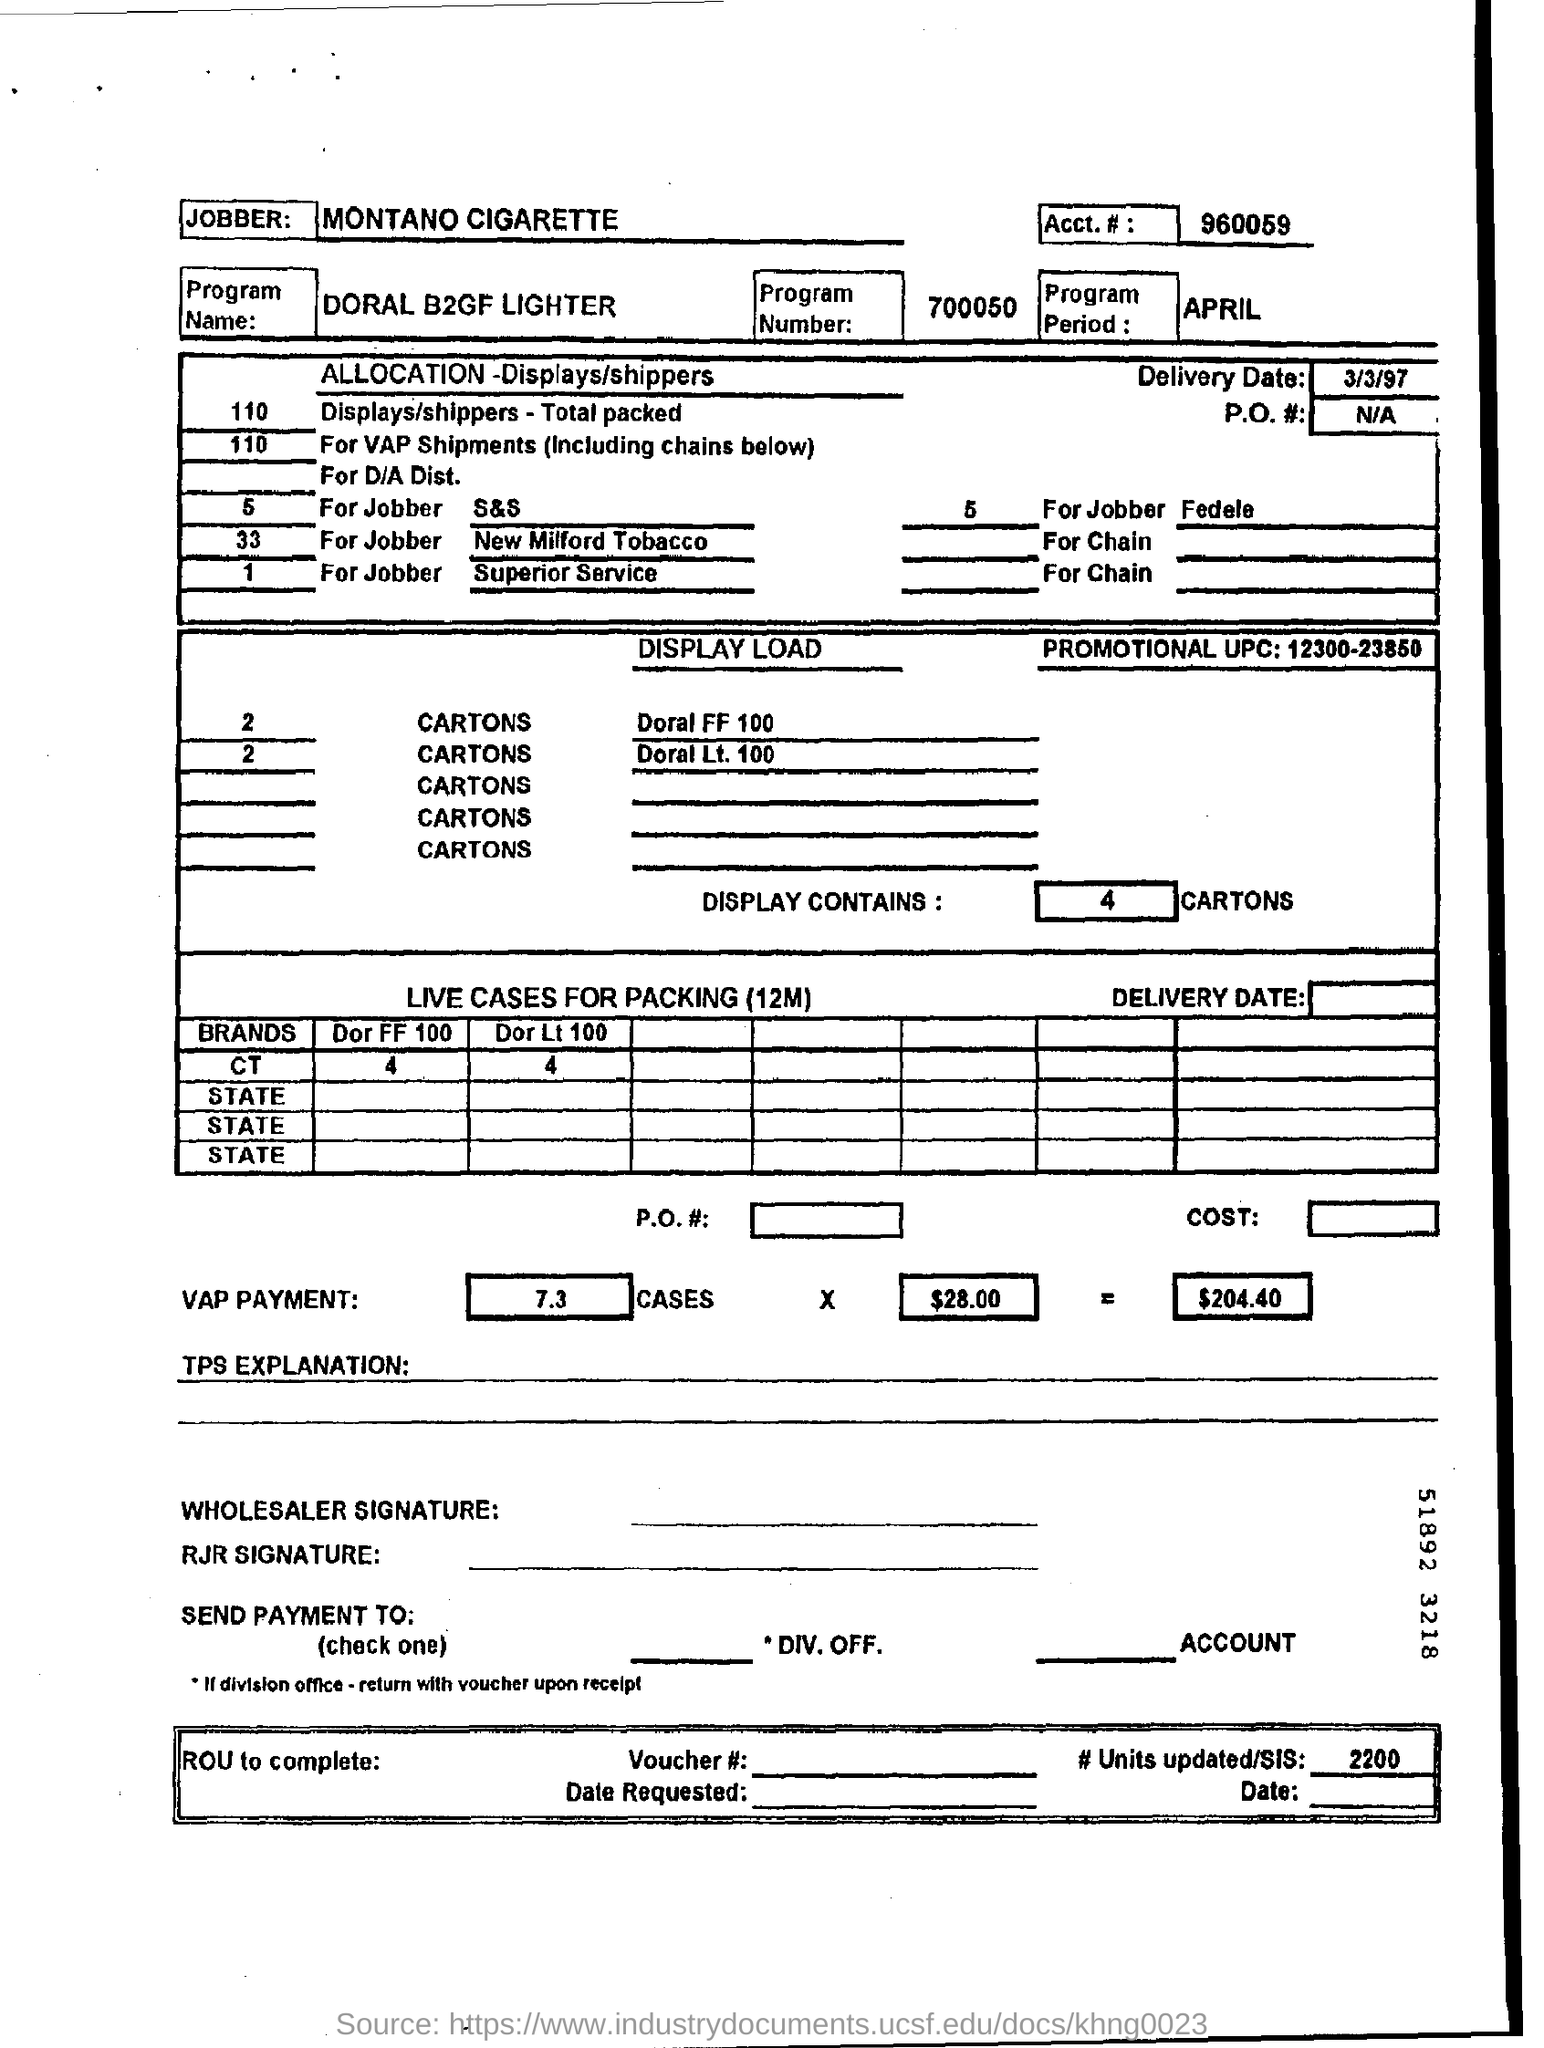What is the Account No. given in the document?
Your answer should be very brief. 960059. What is the program Number mentioned in this document?
Offer a very short reply. 700050. What is the Program Name mentioned in this document?
Your response must be concise. DORAL B2GF LIGHTER. What is the delivery date given in the document?
Ensure brevity in your answer.  3/3/97. What is the Promotional UPC  mentioned in the document?
Offer a very short reply. 12300-23850. What is the no of units updated/SIS given in the document?
Provide a succinct answer. 2200. 